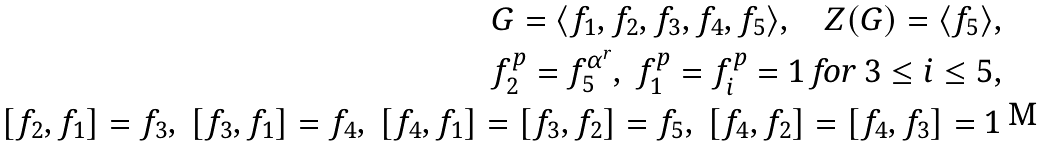Convert formula to latex. <formula><loc_0><loc_0><loc_500><loc_500>G = \langle f _ { 1 } , f _ { 2 } , f _ { 3 } , f _ { 4 } , f _ { 5 } \rangle , \quad Z ( G ) = \langle f _ { 5 } \rangle , \\ f _ { 2 } ^ { p } = f _ { 5 } ^ { \alpha ^ { r } } , \ f _ { 1 } ^ { p } = f _ { i } ^ { p } = 1 \text { for } 3 \leq i \leq 5 , \\ [ f _ { 2 } , f _ { 1 } ] = f _ { 3 } , \ [ f _ { 3 } , f _ { 1 } ] = f _ { 4 } , \ [ f _ { 4 } , f _ { 1 } ] = [ f _ { 3 } , f _ { 2 } ] = f _ { 5 } , \ [ f _ { 4 } , f _ { 2 } ] = [ f _ { 4 } , f _ { 3 } ] = 1</formula> 